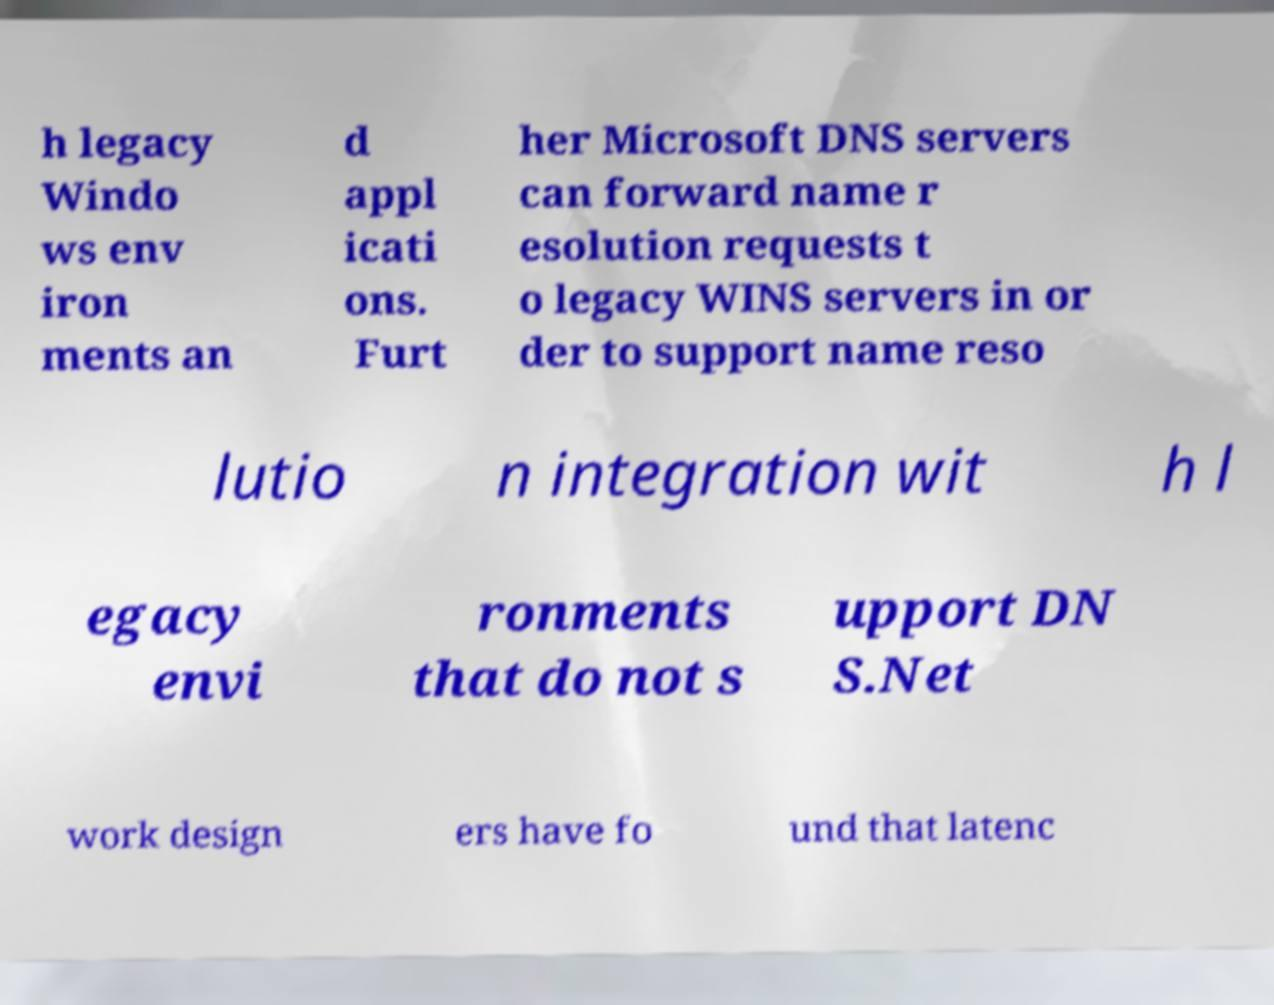What messages or text are displayed in this image? I need them in a readable, typed format. h legacy Windo ws env iron ments an d appl icati ons. Furt her Microsoft DNS servers can forward name r esolution requests t o legacy WINS servers in or der to support name reso lutio n integration wit h l egacy envi ronments that do not s upport DN S.Net work design ers have fo und that latenc 